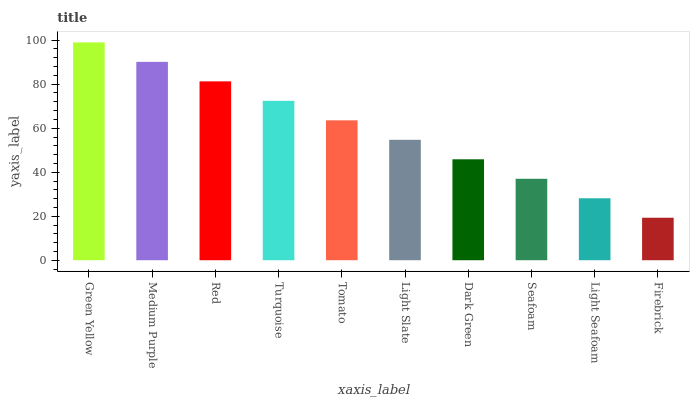Is Firebrick the minimum?
Answer yes or no. Yes. Is Green Yellow the maximum?
Answer yes or no. Yes. Is Medium Purple the minimum?
Answer yes or no. No. Is Medium Purple the maximum?
Answer yes or no. No. Is Green Yellow greater than Medium Purple?
Answer yes or no. Yes. Is Medium Purple less than Green Yellow?
Answer yes or no. Yes. Is Medium Purple greater than Green Yellow?
Answer yes or no. No. Is Green Yellow less than Medium Purple?
Answer yes or no. No. Is Tomato the high median?
Answer yes or no. Yes. Is Light Slate the low median?
Answer yes or no. Yes. Is Red the high median?
Answer yes or no. No. Is Seafoam the low median?
Answer yes or no. No. 